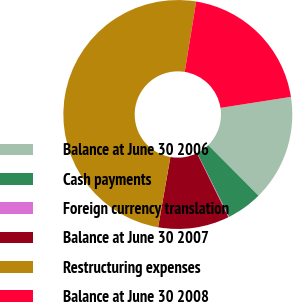<chart> <loc_0><loc_0><loc_500><loc_500><pie_chart><fcel>Balance at June 30 2006<fcel>Cash payments<fcel>Foreign currency translation<fcel>Balance at June 30 2007<fcel>Restructuring expenses<fcel>Balance at June 30 2008<nl><fcel>15.01%<fcel>5.07%<fcel>0.1%<fcel>10.04%<fcel>49.8%<fcel>19.98%<nl></chart> 